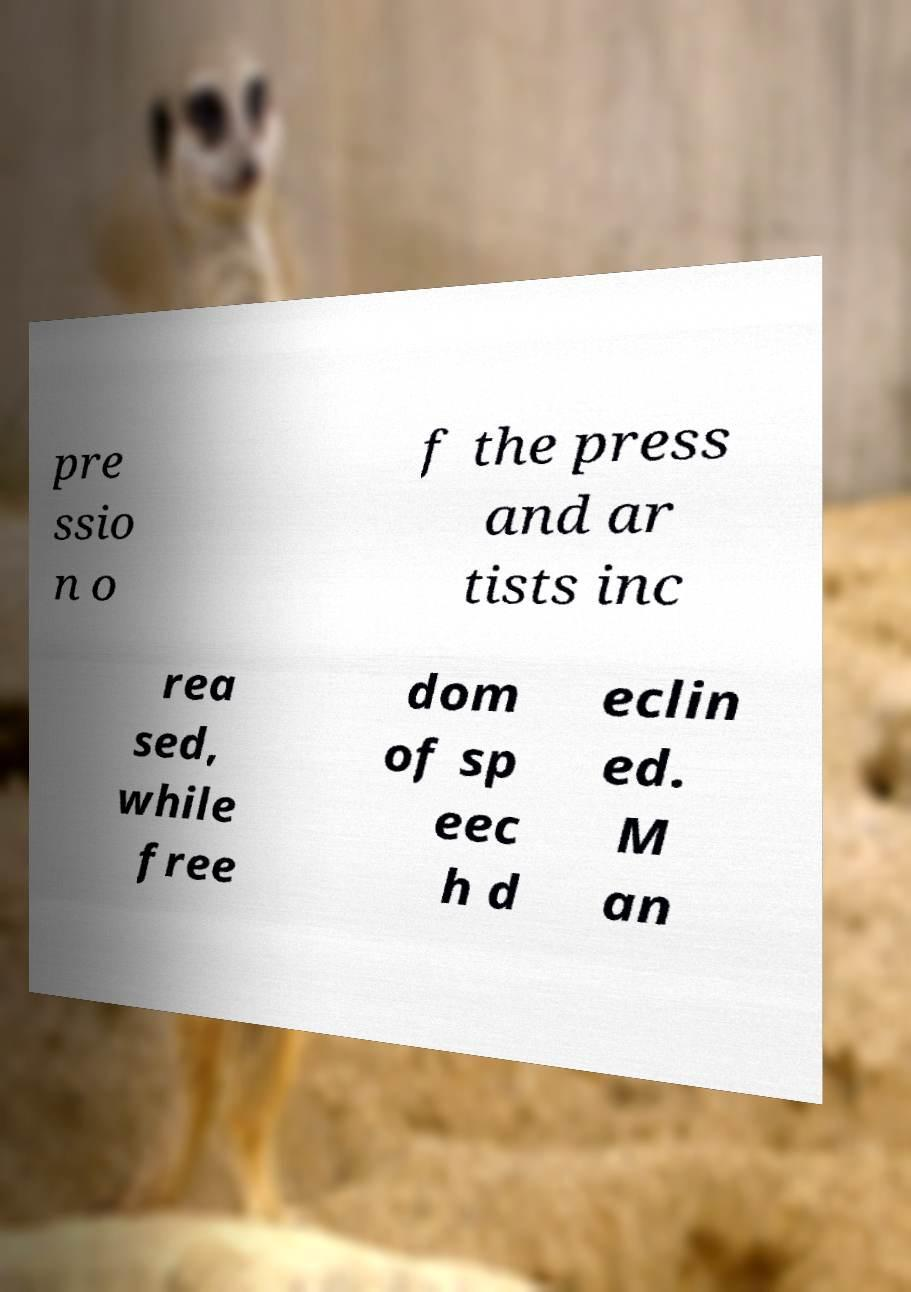Could you extract and type out the text from this image? pre ssio n o f the press and ar tists inc rea sed, while free dom of sp eec h d eclin ed. M an 